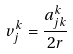<formula> <loc_0><loc_0><loc_500><loc_500>v _ { j } ^ { k } = \frac { a _ { j k } ^ { k } } { 2 r }</formula> 